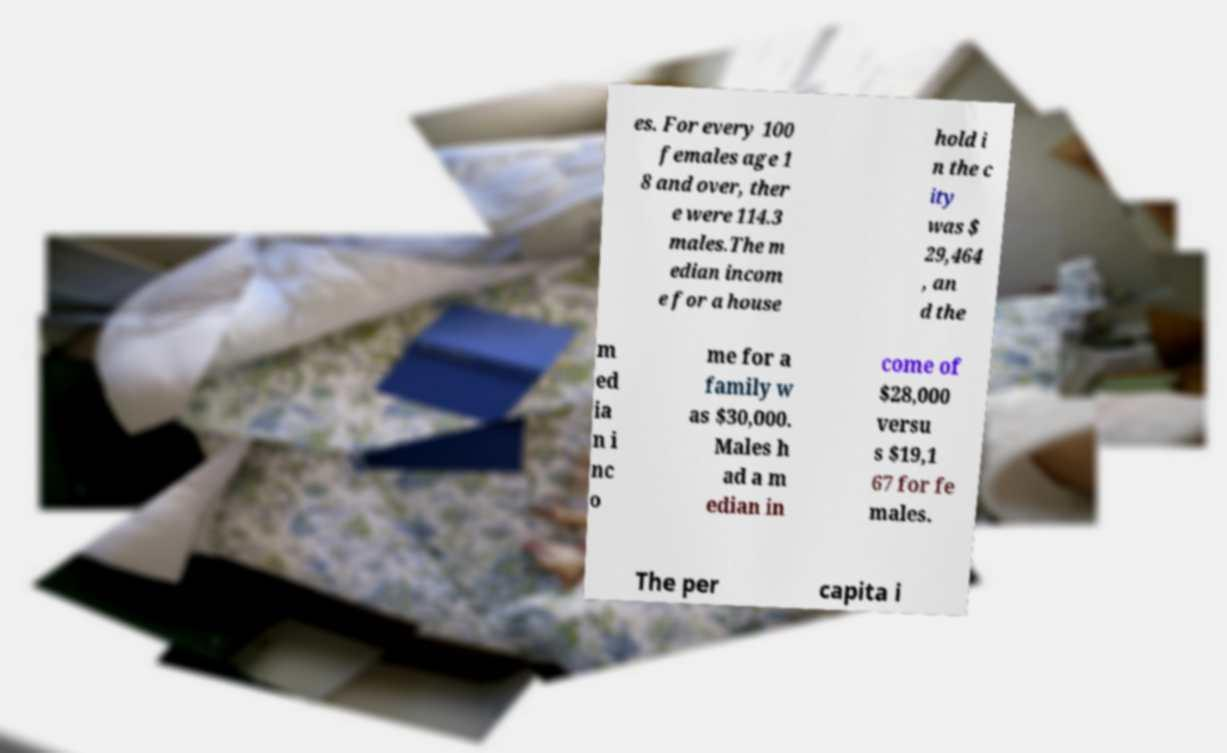What messages or text are displayed in this image? I need them in a readable, typed format. es. For every 100 females age 1 8 and over, ther e were 114.3 males.The m edian incom e for a house hold i n the c ity was $ 29,464 , an d the m ed ia n i nc o me for a family w as $30,000. Males h ad a m edian in come of $28,000 versu s $19,1 67 for fe males. The per capita i 